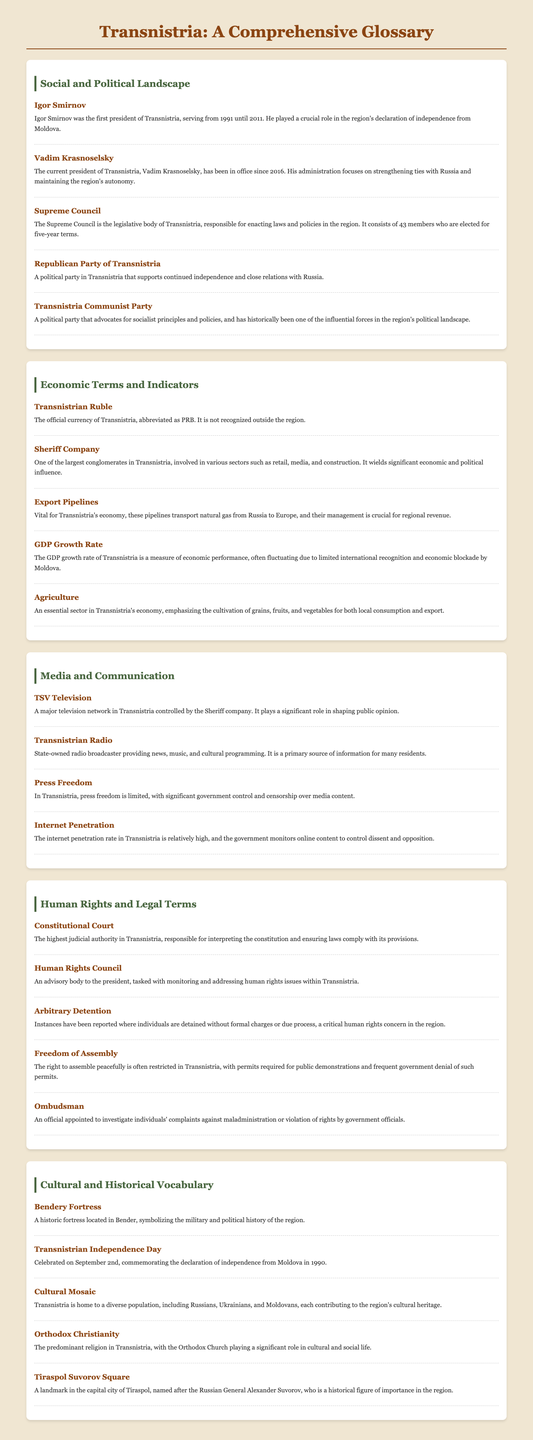What is the name of the first president of Transnistria? The first president of Transnistria mentioned in the document is Igor Smirnov.
Answer: Igor Smirnov Who is the current president of Transnistria? The document states that Vadim Krasnoselsky is the current president of Transnistria.
Answer: Vadim Krasnoselsky How many members are in the Supreme Council? The number of members in the Supreme Council is specified as 43.
Answer: 43 What is the official currency of Transnistria? The glossary lists the official currency as the Transnistrian Ruble, abbreviated as PRB.
Answer: Transnistrian Ruble What date is Transnistrian Independence Day celebrated? The document indicates that Transnistrian Independence Day is celebrated on September 2nd.
Answer: September 2nd Which company is involved in various sectors and wields significant influence in Transnistria? The company identified in the document as one of the largest is the Sheriff Company.
Answer: Sheriff Company What is the predominant religion in Transnistria? The document states that Orthodox Christianity is the predominant religion in Transnistria.
Answer: Orthodox Christianity What role does the Human Rights Council serve in Transnistria? The Human Rights Council is an advisory body tasked with monitoring human rights issues.
Answer: Monitoring human rights issues What is a major television network controlled by the Sheriff company? The major television network mentioned in the document is TSV Television.
Answer: TSV Television What is the highest judicial authority in Transnistria? The document identifies the Constitutional Court as the highest judicial authority.
Answer: Constitutional Court 